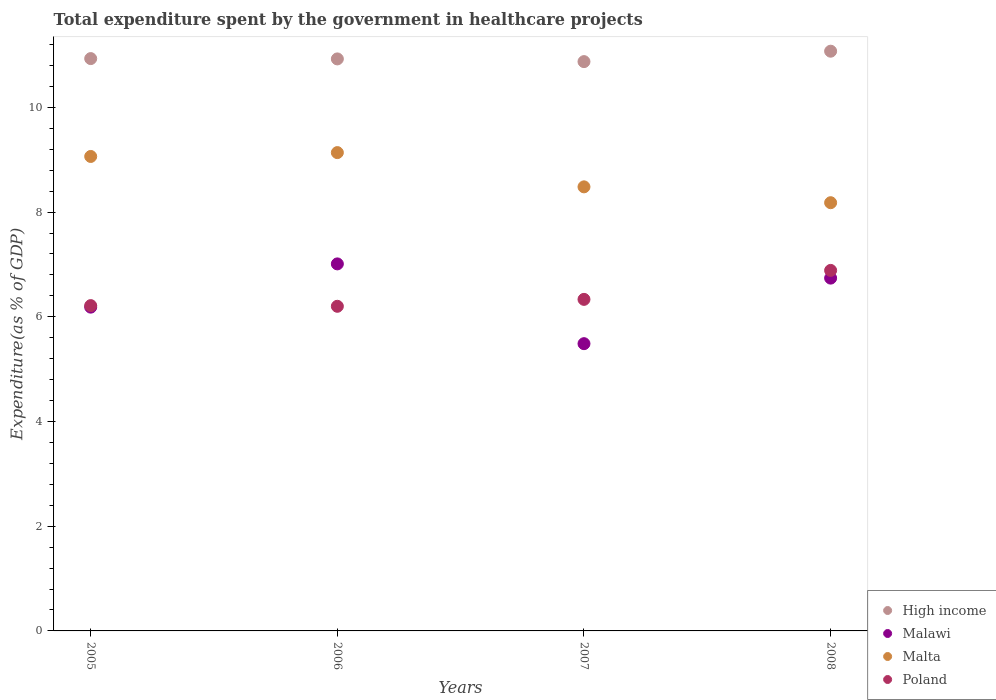What is the total expenditure spent by the government in healthcare projects in Malawi in 2005?
Give a very brief answer. 6.18. Across all years, what is the maximum total expenditure spent by the government in healthcare projects in Malta?
Provide a succinct answer. 9.14. Across all years, what is the minimum total expenditure spent by the government in healthcare projects in High income?
Make the answer very short. 10.87. What is the total total expenditure spent by the government in healthcare projects in Malawi in the graph?
Offer a very short reply. 25.42. What is the difference between the total expenditure spent by the government in healthcare projects in Malta in 2005 and that in 2007?
Your answer should be compact. 0.58. What is the difference between the total expenditure spent by the government in healthcare projects in Malta in 2005 and the total expenditure spent by the government in healthcare projects in Poland in 2008?
Ensure brevity in your answer.  2.18. What is the average total expenditure spent by the government in healthcare projects in Malawi per year?
Offer a very short reply. 6.36. In the year 2005, what is the difference between the total expenditure spent by the government in healthcare projects in Malawi and total expenditure spent by the government in healthcare projects in High income?
Keep it short and to the point. -4.75. What is the ratio of the total expenditure spent by the government in healthcare projects in Poland in 2006 to that in 2008?
Provide a short and direct response. 0.9. Is the total expenditure spent by the government in healthcare projects in Malta in 2007 less than that in 2008?
Your answer should be compact. No. Is the difference between the total expenditure spent by the government in healthcare projects in Malawi in 2005 and 2006 greater than the difference between the total expenditure spent by the government in healthcare projects in High income in 2005 and 2006?
Offer a terse response. No. What is the difference between the highest and the second highest total expenditure spent by the government in healthcare projects in Malta?
Provide a short and direct response. 0.07. What is the difference between the highest and the lowest total expenditure spent by the government in healthcare projects in Poland?
Your answer should be very brief. 0.69. In how many years, is the total expenditure spent by the government in healthcare projects in Malawi greater than the average total expenditure spent by the government in healthcare projects in Malawi taken over all years?
Give a very brief answer. 2. Is it the case that in every year, the sum of the total expenditure spent by the government in healthcare projects in Malawi and total expenditure spent by the government in healthcare projects in Malta  is greater than the sum of total expenditure spent by the government in healthcare projects in Poland and total expenditure spent by the government in healthcare projects in High income?
Keep it short and to the point. No. Is the total expenditure spent by the government in healthcare projects in Malawi strictly less than the total expenditure spent by the government in healthcare projects in High income over the years?
Give a very brief answer. Yes. How many years are there in the graph?
Provide a succinct answer. 4. Does the graph contain any zero values?
Keep it short and to the point. No. Does the graph contain grids?
Make the answer very short. No. What is the title of the graph?
Ensure brevity in your answer.  Total expenditure spent by the government in healthcare projects. Does "Liberia" appear as one of the legend labels in the graph?
Make the answer very short. No. What is the label or title of the X-axis?
Your answer should be very brief. Years. What is the label or title of the Y-axis?
Ensure brevity in your answer.  Expenditure(as % of GDP). What is the Expenditure(as % of GDP) of High income in 2005?
Keep it short and to the point. 10.93. What is the Expenditure(as % of GDP) in Malawi in 2005?
Ensure brevity in your answer.  6.18. What is the Expenditure(as % of GDP) in Malta in 2005?
Ensure brevity in your answer.  9.06. What is the Expenditure(as % of GDP) of Poland in 2005?
Give a very brief answer. 6.21. What is the Expenditure(as % of GDP) of High income in 2006?
Ensure brevity in your answer.  10.93. What is the Expenditure(as % of GDP) in Malawi in 2006?
Offer a terse response. 7.01. What is the Expenditure(as % of GDP) in Malta in 2006?
Provide a succinct answer. 9.14. What is the Expenditure(as % of GDP) of Poland in 2006?
Offer a terse response. 6.2. What is the Expenditure(as % of GDP) of High income in 2007?
Make the answer very short. 10.87. What is the Expenditure(as % of GDP) in Malawi in 2007?
Give a very brief answer. 5.49. What is the Expenditure(as % of GDP) in Malta in 2007?
Your response must be concise. 8.48. What is the Expenditure(as % of GDP) of Poland in 2007?
Make the answer very short. 6.33. What is the Expenditure(as % of GDP) in High income in 2008?
Keep it short and to the point. 11.07. What is the Expenditure(as % of GDP) of Malawi in 2008?
Make the answer very short. 6.74. What is the Expenditure(as % of GDP) in Malta in 2008?
Your answer should be very brief. 8.18. What is the Expenditure(as % of GDP) in Poland in 2008?
Offer a very short reply. 6.89. Across all years, what is the maximum Expenditure(as % of GDP) of High income?
Make the answer very short. 11.07. Across all years, what is the maximum Expenditure(as % of GDP) of Malawi?
Your response must be concise. 7.01. Across all years, what is the maximum Expenditure(as % of GDP) of Malta?
Keep it short and to the point. 9.14. Across all years, what is the maximum Expenditure(as % of GDP) in Poland?
Your answer should be very brief. 6.89. Across all years, what is the minimum Expenditure(as % of GDP) of High income?
Offer a terse response. 10.87. Across all years, what is the minimum Expenditure(as % of GDP) in Malawi?
Give a very brief answer. 5.49. Across all years, what is the minimum Expenditure(as % of GDP) in Malta?
Offer a very short reply. 8.18. Across all years, what is the minimum Expenditure(as % of GDP) in Poland?
Your response must be concise. 6.2. What is the total Expenditure(as % of GDP) of High income in the graph?
Offer a very short reply. 43.81. What is the total Expenditure(as % of GDP) of Malawi in the graph?
Ensure brevity in your answer.  25.42. What is the total Expenditure(as % of GDP) in Malta in the graph?
Your answer should be compact. 34.86. What is the total Expenditure(as % of GDP) in Poland in the graph?
Your answer should be very brief. 25.63. What is the difference between the Expenditure(as % of GDP) of High income in 2005 and that in 2006?
Keep it short and to the point. 0.01. What is the difference between the Expenditure(as % of GDP) in Malawi in 2005 and that in 2006?
Your response must be concise. -0.83. What is the difference between the Expenditure(as % of GDP) of Malta in 2005 and that in 2006?
Give a very brief answer. -0.07. What is the difference between the Expenditure(as % of GDP) in Poland in 2005 and that in 2006?
Your answer should be very brief. 0.01. What is the difference between the Expenditure(as % of GDP) in High income in 2005 and that in 2007?
Offer a terse response. 0.06. What is the difference between the Expenditure(as % of GDP) of Malawi in 2005 and that in 2007?
Ensure brevity in your answer.  0.7. What is the difference between the Expenditure(as % of GDP) of Malta in 2005 and that in 2007?
Give a very brief answer. 0.58. What is the difference between the Expenditure(as % of GDP) of Poland in 2005 and that in 2007?
Offer a terse response. -0.12. What is the difference between the Expenditure(as % of GDP) in High income in 2005 and that in 2008?
Your answer should be very brief. -0.14. What is the difference between the Expenditure(as % of GDP) in Malawi in 2005 and that in 2008?
Keep it short and to the point. -0.55. What is the difference between the Expenditure(as % of GDP) in Malta in 2005 and that in 2008?
Give a very brief answer. 0.88. What is the difference between the Expenditure(as % of GDP) of Poland in 2005 and that in 2008?
Make the answer very short. -0.67. What is the difference between the Expenditure(as % of GDP) of High income in 2006 and that in 2007?
Make the answer very short. 0.05. What is the difference between the Expenditure(as % of GDP) in Malawi in 2006 and that in 2007?
Your response must be concise. 1.52. What is the difference between the Expenditure(as % of GDP) in Malta in 2006 and that in 2007?
Offer a very short reply. 0.65. What is the difference between the Expenditure(as % of GDP) of Poland in 2006 and that in 2007?
Your response must be concise. -0.13. What is the difference between the Expenditure(as % of GDP) in High income in 2006 and that in 2008?
Offer a terse response. -0.15. What is the difference between the Expenditure(as % of GDP) in Malawi in 2006 and that in 2008?
Offer a terse response. 0.27. What is the difference between the Expenditure(as % of GDP) of Malta in 2006 and that in 2008?
Give a very brief answer. 0.96. What is the difference between the Expenditure(as % of GDP) in Poland in 2006 and that in 2008?
Keep it short and to the point. -0.69. What is the difference between the Expenditure(as % of GDP) of High income in 2007 and that in 2008?
Keep it short and to the point. -0.2. What is the difference between the Expenditure(as % of GDP) of Malawi in 2007 and that in 2008?
Provide a short and direct response. -1.25. What is the difference between the Expenditure(as % of GDP) in Malta in 2007 and that in 2008?
Provide a succinct answer. 0.3. What is the difference between the Expenditure(as % of GDP) of Poland in 2007 and that in 2008?
Offer a very short reply. -0.55. What is the difference between the Expenditure(as % of GDP) of High income in 2005 and the Expenditure(as % of GDP) of Malawi in 2006?
Keep it short and to the point. 3.92. What is the difference between the Expenditure(as % of GDP) of High income in 2005 and the Expenditure(as % of GDP) of Malta in 2006?
Give a very brief answer. 1.8. What is the difference between the Expenditure(as % of GDP) in High income in 2005 and the Expenditure(as % of GDP) in Poland in 2006?
Ensure brevity in your answer.  4.73. What is the difference between the Expenditure(as % of GDP) in Malawi in 2005 and the Expenditure(as % of GDP) in Malta in 2006?
Your answer should be compact. -2.95. What is the difference between the Expenditure(as % of GDP) of Malawi in 2005 and the Expenditure(as % of GDP) of Poland in 2006?
Offer a terse response. -0.02. What is the difference between the Expenditure(as % of GDP) of Malta in 2005 and the Expenditure(as % of GDP) of Poland in 2006?
Provide a succinct answer. 2.86. What is the difference between the Expenditure(as % of GDP) in High income in 2005 and the Expenditure(as % of GDP) in Malawi in 2007?
Ensure brevity in your answer.  5.45. What is the difference between the Expenditure(as % of GDP) in High income in 2005 and the Expenditure(as % of GDP) in Malta in 2007?
Provide a succinct answer. 2.45. What is the difference between the Expenditure(as % of GDP) of High income in 2005 and the Expenditure(as % of GDP) of Poland in 2007?
Provide a short and direct response. 4.6. What is the difference between the Expenditure(as % of GDP) in Malawi in 2005 and the Expenditure(as % of GDP) in Malta in 2007?
Provide a succinct answer. -2.3. What is the difference between the Expenditure(as % of GDP) of Malawi in 2005 and the Expenditure(as % of GDP) of Poland in 2007?
Offer a terse response. -0.15. What is the difference between the Expenditure(as % of GDP) in Malta in 2005 and the Expenditure(as % of GDP) in Poland in 2007?
Keep it short and to the point. 2.73. What is the difference between the Expenditure(as % of GDP) of High income in 2005 and the Expenditure(as % of GDP) of Malawi in 2008?
Offer a very short reply. 4.19. What is the difference between the Expenditure(as % of GDP) of High income in 2005 and the Expenditure(as % of GDP) of Malta in 2008?
Your answer should be very brief. 2.75. What is the difference between the Expenditure(as % of GDP) of High income in 2005 and the Expenditure(as % of GDP) of Poland in 2008?
Your answer should be very brief. 4.05. What is the difference between the Expenditure(as % of GDP) in Malawi in 2005 and the Expenditure(as % of GDP) in Malta in 2008?
Ensure brevity in your answer.  -1.99. What is the difference between the Expenditure(as % of GDP) in Malawi in 2005 and the Expenditure(as % of GDP) in Poland in 2008?
Your response must be concise. -0.7. What is the difference between the Expenditure(as % of GDP) in Malta in 2005 and the Expenditure(as % of GDP) in Poland in 2008?
Offer a terse response. 2.18. What is the difference between the Expenditure(as % of GDP) of High income in 2006 and the Expenditure(as % of GDP) of Malawi in 2007?
Provide a short and direct response. 5.44. What is the difference between the Expenditure(as % of GDP) in High income in 2006 and the Expenditure(as % of GDP) in Malta in 2007?
Make the answer very short. 2.44. What is the difference between the Expenditure(as % of GDP) of High income in 2006 and the Expenditure(as % of GDP) of Poland in 2007?
Offer a very short reply. 4.59. What is the difference between the Expenditure(as % of GDP) in Malawi in 2006 and the Expenditure(as % of GDP) in Malta in 2007?
Provide a succinct answer. -1.47. What is the difference between the Expenditure(as % of GDP) of Malawi in 2006 and the Expenditure(as % of GDP) of Poland in 2007?
Provide a short and direct response. 0.68. What is the difference between the Expenditure(as % of GDP) of Malta in 2006 and the Expenditure(as % of GDP) of Poland in 2007?
Ensure brevity in your answer.  2.8. What is the difference between the Expenditure(as % of GDP) of High income in 2006 and the Expenditure(as % of GDP) of Malawi in 2008?
Your answer should be compact. 4.19. What is the difference between the Expenditure(as % of GDP) of High income in 2006 and the Expenditure(as % of GDP) of Malta in 2008?
Make the answer very short. 2.75. What is the difference between the Expenditure(as % of GDP) of High income in 2006 and the Expenditure(as % of GDP) of Poland in 2008?
Offer a terse response. 4.04. What is the difference between the Expenditure(as % of GDP) of Malawi in 2006 and the Expenditure(as % of GDP) of Malta in 2008?
Offer a very short reply. -1.17. What is the difference between the Expenditure(as % of GDP) of Malawi in 2006 and the Expenditure(as % of GDP) of Poland in 2008?
Provide a short and direct response. 0.12. What is the difference between the Expenditure(as % of GDP) of Malta in 2006 and the Expenditure(as % of GDP) of Poland in 2008?
Your answer should be compact. 2.25. What is the difference between the Expenditure(as % of GDP) in High income in 2007 and the Expenditure(as % of GDP) in Malawi in 2008?
Offer a terse response. 4.14. What is the difference between the Expenditure(as % of GDP) of High income in 2007 and the Expenditure(as % of GDP) of Malta in 2008?
Provide a short and direct response. 2.69. What is the difference between the Expenditure(as % of GDP) of High income in 2007 and the Expenditure(as % of GDP) of Poland in 2008?
Give a very brief answer. 3.99. What is the difference between the Expenditure(as % of GDP) in Malawi in 2007 and the Expenditure(as % of GDP) in Malta in 2008?
Your response must be concise. -2.69. What is the difference between the Expenditure(as % of GDP) of Malawi in 2007 and the Expenditure(as % of GDP) of Poland in 2008?
Keep it short and to the point. -1.4. What is the difference between the Expenditure(as % of GDP) in Malta in 2007 and the Expenditure(as % of GDP) in Poland in 2008?
Ensure brevity in your answer.  1.6. What is the average Expenditure(as % of GDP) in High income per year?
Offer a terse response. 10.95. What is the average Expenditure(as % of GDP) of Malawi per year?
Your answer should be very brief. 6.36. What is the average Expenditure(as % of GDP) of Malta per year?
Give a very brief answer. 8.72. What is the average Expenditure(as % of GDP) of Poland per year?
Ensure brevity in your answer.  6.41. In the year 2005, what is the difference between the Expenditure(as % of GDP) in High income and Expenditure(as % of GDP) in Malawi?
Provide a succinct answer. 4.75. In the year 2005, what is the difference between the Expenditure(as % of GDP) in High income and Expenditure(as % of GDP) in Malta?
Provide a succinct answer. 1.87. In the year 2005, what is the difference between the Expenditure(as % of GDP) of High income and Expenditure(as % of GDP) of Poland?
Make the answer very short. 4.72. In the year 2005, what is the difference between the Expenditure(as % of GDP) of Malawi and Expenditure(as % of GDP) of Malta?
Offer a very short reply. -2.88. In the year 2005, what is the difference between the Expenditure(as % of GDP) in Malawi and Expenditure(as % of GDP) in Poland?
Ensure brevity in your answer.  -0.03. In the year 2005, what is the difference between the Expenditure(as % of GDP) of Malta and Expenditure(as % of GDP) of Poland?
Offer a very short reply. 2.85. In the year 2006, what is the difference between the Expenditure(as % of GDP) of High income and Expenditure(as % of GDP) of Malawi?
Your response must be concise. 3.92. In the year 2006, what is the difference between the Expenditure(as % of GDP) of High income and Expenditure(as % of GDP) of Malta?
Offer a terse response. 1.79. In the year 2006, what is the difference between the Expenditure(as % of GDP) of High income and Expenditure(as % of GDP) of Poland?
Provide a succinct answer. 4.73. In the year 2006, what is the difference between the Expenditure(as % of GDP) in Malawi and Expenditure(as % of GDP) in Malta?
Give a very brief answer. -2.13. In the year 2006, what is the difference between the Expenditure(as % of GDP) in Malawi and Expenditure(as % of GDP) in Poland?
Give a very brief answer. 0.81. In the year 2006, what is the difference between the Expenditure(as % of GDP) in Malta and Expenditure(as % of GDP) in Poland?
Your response must be concise. 2.94. In the year 2007, what is the difference between the Expenditure(as % of GDP) of High income and Expenditure(as % of GDP) of Malawi?
Make the answer very short. 5.39. In the year 2007, what is the difference between the Expenditure(as % of GDP) of High income and Expenditure(as % of GDP) of Malta?
Offer a very short reply. 2.39. In the year 2007, what is the difference between the Expenditure(as % of GDP) in High income and Expenditure(as % of GDP) in Poland?
Ensure brevity in your answer.  4.54. In the year 2007, what is the difference between the Expenditure(as % of GDP) in Malawi and Expenditure(as % of GDP) in Malta?
Provide a short and direct response. -3. In the year 2007, what is the difference between the Expenditure(as % of GDP) of Malawi and Expenditure(as % of GDP) of Poland?
Ensure brevity in your answer.  -0.85. In the year 2007, what is the difference between the Expenditure(as % of GDP) of Malta and Expenditure(as % of GDP) of Poland?
Your answer should be compact. 2.15. In the year 2008, what is the difference between the Expenditure(as % of GDP) of High income and Expenditure(as % of GDP) of Malawi?
Ensure brevity in your answer.  4.33. In the year 2008, what is the difference between the Expenditure(as % of GDP) in High income and Expenditure(as % of GDP) in Malta?
Ensure brevity in your answer.  2.89. In the year 2008, what is the difference between the Expenditure(as % of GDP) of High income and Expenditure(as % of GDP) of Poland?
Provide a succinct answer. 4.19. In the year 2008, what is the difference between the Expenditure(as % of GDP) in Malawi and Expenditure(as % of GDP) in Malta?
Ensure brevity in your answer.  -1.44. In the year 2008, what is the difference between the Expenditure(as % of GDP) in Malawi and Expenditure(as % of GDP) in Poland?
Your answer should be very brief. -0.15. In the year 2008, what is the difference between the Expenditure(as % of GDP) in Malta and Expenditure(as % of GDP) in Poland?
Make the answer very short. 1.29. What is the ratio of the Expenditure(as % of GDP) in Malawi in 2005 to that in 2006?
Your answer should be compact. 0.88. What is the ratio of the Expenditure(as % of GDP) in Poland in 2005 to that in 2006?
Keep it short and to the point. 1. What is the ratio of the Expenditure(as % of GDP) of High income in 2005 to that in 2007?
Provide a short and direct response. 1.01. What is the ratio of the Expenditure(as % of GDP) in Malawi in 2005 to that in 2007?
Your response must be concise. 1.13. What is the ratio of the Expenditure(as % of GDP) in Malta in 2005 to that in 2007?
Offer a very short reply. 1.07. What is the ratio of the Expenditure(as % of GDP) of Poland in 2005 to that in 2007?
Ensure brevity in your answer.  0.98. What is the ratio of the Expenditure(as % of GDP) in High income in 2005 to that in 2008?
Your response must be concise. 0.99. What is the ratio of the Expenditure(as % of GDP) of Malawi in 2005 to that in 2008?
Keep it short and to the point. 0.92. What is the ratio of the Expenditure(as % of GDP) in Malta in 2005 to that in 2008?
Ensure brevity in your answer.  1.11. What is the ratio of the Expenditure(as % of GDP) of Poland in 2005 to that in 2008?
Ensure brevity in your answer.  0.9. What is the ratio of the Expenditure(as % of GDP) in Malawi in 2006 to that in 2007?
Keep it short and to the point. 1.28. What is the ratio of the Expenditure(as % of GDP) in Malta in 2006 to that in 2007?
Offer a very short reply. 1.08. What is the ratio of the Expenditure(as % of GDP) in Poland in 2006 to that in 2007?
Offer a very short reply. 0.98. What is the ratio of the Expenditure(as % of GDP) in High income in 2006 to that in 2008?
Provide a succinct answer. 0.99. What is the ratio of the Expenditure(as % of GDP) of Malawi in 2006 to that in 2008?
Give a very brief answer. 1.04. What is the ratio of the Expenditure(as % of GDP) of Malta in 2006 to that in 2008?
Provide a succinct answer. 1.12. What is the ratio of the Expenditure(as % of GDP) in Poland in 2006 to that in 2008?
Provide a short and direct response. 0.9. What is the ratio of the Expenditure(as % of GDP) of High income in 2007 to that in 2008?
Make the answer very short. 0.98. What is the ratio of the Expenditure(as % of GDP) of Malawi in 2007 to that in 2008?
Provide a short and direct response. 0.81. What is the ratio of the Expenditure(as % of GDP) of Poland in 2007 to that in 2008?
Give a very brief answer. 0.92. What is the difference between the highest and the second highest Expenditure(as % of GDP) of High income?
Offer a very short reply. 0.14. What is the difference between the highest and the second highest Expenditure(as % of GDP) in Malawi?
Give a very brief answer. 0.27. What is the difference between the highest and the second highest Expenditure(as % of GDP) in Malta?
Provide a succinct answer. 0.07. What is the difference between the highest and the second highest Expenditure(as % of GDP) of Poland?
Offer a very short reply. 0.55. What is the difference between the highest and the lowest Expenditure(as % of GDP) of High income?
Your answer should be compact. 0.2. What is the difference between the highest and the lowest Expenditure(as % of GDP) of Malawi?
Make the answer very short. 1.52. What is the difference between the highest and the lowest Expenditure(as % of GDP) in Malta?
Your answer should be compact. 0.96. What is the difference between the highest and the lowest Expenditure(as % of GDP) in Poland?
Your answer should be compact. 0.69. 